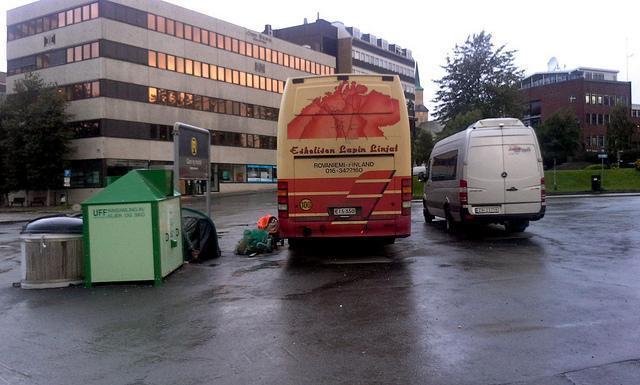How many buses are visible?
Give a very brief answer. 2. How many trucks can be seen?
Give a very brief answer. 1. How many people are wearing hats?
Give a very brief answer. 0. 